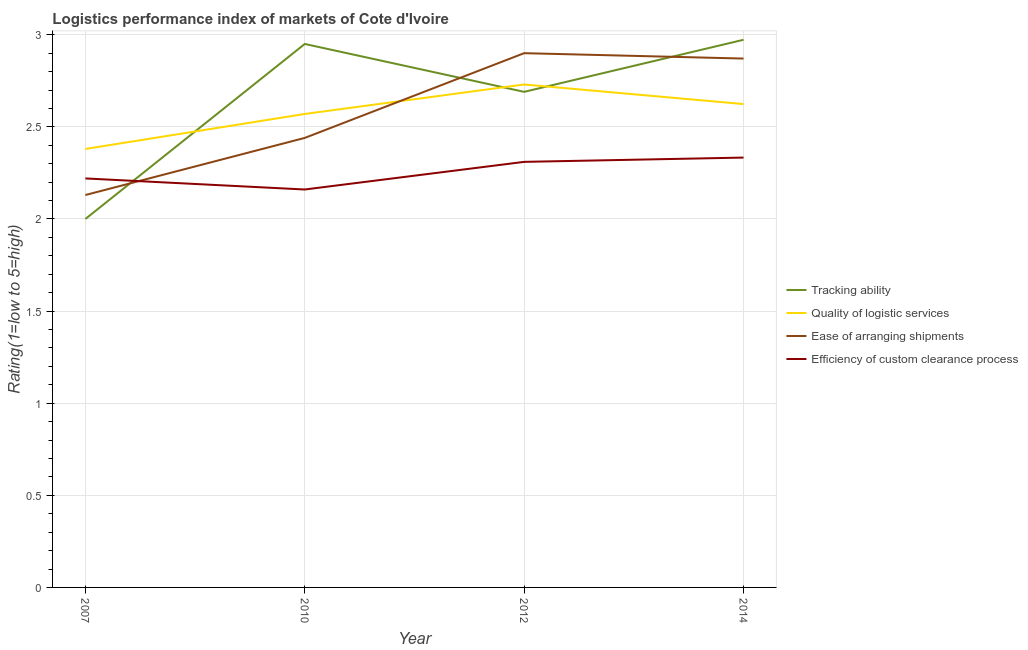How many different coloured lines are there?
Make the answer very short. 4. Does the line corresponding to lpi rating of efficiency of custom clearance process intersect with the line corresponding to lpi rating of quality of logistic services?
Provide a succinct answer. No. Is the number of lines equal to the number of legend labels?
Your response must be concise. Yes. What is the lpi rating of tracking ability in 2007?
Make the answer very short. 2. Across all years, what is the minimum lpi rating of ease of arranging shipments?
Ensure brevity in your answer.  2.13. In which year was the lpi rating of quality of logistic services maximum?
Your answer should be compact. 2012. What is the total lpi rating of efficiency of custom clearance process in the graph?
Offer a very short reply. 9.02. What is the difference between the lpi rating of quality of logistic services in 2012 and that in 2014?
Your answer should be very brief. 0.11. What is the difference between the lpi rating of quality of logistic services in 2014 and the lpi rating of ease of arranging shipments in 2007?
Make the answer very short. 0.49. What is the average lpi rating of ease of arranging shipments per year?
Offer a very short reply. 2.59. In the year 2012, what is the difference between the lpi rating of quality of logistic services and lpi rating of efficiency of custom clearance process?
Make the answer very short. 0.42. What is the ratio of the lpi rating of tracking ability in 2007 to that in 2012?
Your answer should be very brief. 0.74. Is the lpi rating of efficiency of custom clearance process in 2010 less than that in 2012?
Your answer should be compact. Yes. Is the difference between the lpi rating of quality of logistic services in 2007 and 2012 greater than the difference between the lpi rating of ease of arranging shipments in 2007 and 2012?
Give a very brief answer. Yes. What is the difference between the highest and the second highest lpi rating of tracking ability?
Make the answer very short. 0.02. What is the difference between the highest and the lowest lpi rating of ease of arranging shipments?
Offer a terse response. 0.77. In how many years, is the lpi rating of efficiency of custom clearance process greater than the average lpi rating of efficiency of custom clearance process taken over all years?
Your answer should be compact. 2. Is it the case that in every year, the sum of the lpi rating of efficiency of custom clearance process and lpi rating of ease of arranging shipments is greater than the sum of lpi rating of quality of logistic services and lpi rating of tracking ability?
Provide a succinct answer. No. How many lines are there?
Offer a very short reply. 4. Does the graph contain any zero values?
Provide a succinct answer. No. Where does the legend appear in the graph?
Your answer should be compact. Center right. How many legend labels are there?
Your response must be concise. 4. How are the legend labels stacked?
Give a very brief answer. Vertical. What is the title of the graph?
Provide a succinct answer. Logistics performance index of markets of Cote d'Ivoire. Does "Compensation of employees" appear as one of the legend labels in the graph?
Your response must be concise. No. What is the label or title of the X-axis?
Provide a short and direct response. Year. What is the label or title of the Y-axis?
Keep it short and to the point. Rating(1=low to 5=high). What is the Rating(1=low to 5=high) in Tracking ability in 2007?
Offer a very short reply. 2. What is the Rating(1=low to 5=high) of Quality of logistic services in 2007?
Your answer should be compact. 2.38. What is the Rating(1=low to 5=high) in Ease of arranging shipments in 2007?
Provide a succinct answer. 2.13. What is the Rating(1=low to 5=high) in Efficiency of custom clearance process in 2007?
Provide a short and direct response. 2.22. What is the Rating(1=low to 5=high) of Tracking ability in 2010?
Provide a succinct answer. 2.95. What is the Rating(1=low to 5=high) in Quality of logistic services in 2010?
Provide a succinct answer. 2.57. What is the Rating(1=low to 5=high) of Ease of arranging shipments in 2010?
Make the answer very short. 2.44. What is the Rating(1=low to 5=high) in Efficiency of custom clearance process in 2010?
Make the answer very short. 2.16. What is the Rating(1=low to 5=high) of Tracking ability in 2012?
Your answer should be compact. 2.69. What is the Rating(1=low to 5=high) in Quality of logistic services in 2012?
Give a very brief answer. 2.73. What is the Rating(1=low to 5=high) of Ease of arranging shipments in 2012?
Provide a short and direct response. 2.9. What is the Rating(1=low to 5=high) of Efficiency of custom clearance process in 2012?
Offer a terse response. 2.31. What is the Rating(1=low to 5=high) in Tracking ability in 2014?
Provide a short and direct response. 2.97. What is the Rating(1=low to 5=high) of Quality of logistic services in 2014?
Offer a terse response. 2.62. What is the Rating(1=low to 5=high) in Ease of arranging shipments in 2014?
Offer a very short reply. 2.87. What is the Rating(1=low to 5=high) in Efficiency of custom clearance process in 2014?
Your answer should be compact. 2.33. Across all years, what is the maximum Rating(1=low to 5=high) in Tracking ability?
Provide a short and direct response. 2.97. Across all years, what is the maximum Rating(1=low to 5=high) in Quality of logistic services?
Your answer should be very brief. 2.73. Across all years, what is the maximum Rating(1=low to 5=high) in Efficiency of custom clearance process?
Provide a short and direct response. 2.33. Across all years, what is the minimum Rating(1=low to 5=high) in Tracking ability?
Make the answer very short. 2. Across all years, what is the minimum Rating(1=low to 5=high) of Quality of logistic services?
Provide a short and direct response. 2.38. Across all years, what is the minimum Rating(1=low to 5=high) of Ease of arranging shipments?
Offer a very short reply. 2.13. Across all years, what is the minimum Rating(1=low to 5=high) of Efficiency of custom clearance process?
Provide a succinct answer. 2.16. What is the total Rating(1=low to 5=high) in Tracking ability in the graph?
Make the answer very short. 10.61. What is the total Rating(1=low to 5=high) in Quality of logistic services in the graph?
Your response must be concise. 10.3. What is the total Rating(1=low to 5=high) of Ease of arranging shipments in the graph?
Offer a very short reply. 10.34. What is the total Rating(1=low to 5=high) in Efficiency of custom clearance process in the graph?
Offer a very short reply. 9.02. What is the difference between the Rating(1=low to 5=high) of Tracking ability in 2007 and that in 2010?
Provide a short and direct response. -0.95. What is the difference between the Rating(1=low to 5=high) of Quality of logistic services in 2007 and that in 2010?
Give a very brief answer. -0.19. What is the difference between the Rating(1=low to 5=high) in Ease of arranging shipments in 2007 and that in 2010?
Give a very brief answer. -0.31. What is the difference between the Rating(1=low to 5=high) in Tracking ability in 2007 and that in 2012?
Provide a short and direct response. -0.69. What is the difference between the Rating(1=low to 5=high) of Quality of logistic services in 2007 and that in 2012?
Your answer should be compact. -0.35. What is the difference between the Rating(1=low to 5=high) in Ease of arranging shipments in 2007 and that in 2012?
Keep it short and to the point. -0.77. What is the difference between the Rating(1=low to 5=high) in Efficiency of custom clearance process in 2007 and that in 2012?
Make the answer very short. -0.09. What is the difference between the Rating(1=low to 5=high) in Tracking ability in 2007 and that in 2014?
Make the answer very short. -0.97. What is the difference between the Rating(1=low to 5=high) in Quality of logistic services in 2007 and that in 2014?
Give a very brief answer. -0.24. What is the difference between the Rating(1=low to 5=high) of Ease of arranging shipments in 2007 and that in 2014?
Provide a succinct answer. -0.74. What is the difference between the Rating(1=low to 5=high) of Efficiency of custom clearance process in 2007 and that in 2014?
Provide a short and direct response. -0.11. What is the difference between the Rating(1=low to 5=high) of Tracking ability in 2010 and that in 2012?
Provide a succinct answer. 0.26. What is the difference between the Rating(1=low to 5=high) in Quality of logistic services in 2010 and that in 2012?
Offer a very short reply. -0.16. What is the difference between the Rating(1=low to 5=high) in Ease of arranging shipments in 2010 and that in 2012?
Provide a short and direct response. -0.46. What is the difference between the Rating(1=low to 5=high) in Efficiency of custom clearance process in 2010 and that in 2012?
Your answer should be very brief. -0.15. What is the difference between the Rating(1=low to 5=high) of Tracking ability in 2010 and that in 2014?
Offer a very short reply. -0.02. What is the difference between the Rating(1=low to 5=high) of Quality of logistic services in 2010 and that in 2014?
Ensure brevity in your answer.  -0.05. What is the difference between the Rating(1=low to 5=high) in Ease of arranging shipments in 2010 and that in 2014?
Your answer should be compact. -0.43. What is the difference between the Rating(1=low to 5=high) in Efficiency of custom clearance process in 2010 and that in 2014?
Make the answer very short. -0.17. What is the difference between the Rating(1=low to 5=high) in Tracking ability in 2012 and that in 2014?
Offer a very short reply. -0.28. What is the difference between the Rating(1=low to 5=high) in Quality of logistic services in 2012 and that in 2014?
Offer a very short reply. 0.11. What is the difference between the Rating(1=low to 5=high) of Ease of arranging shipments in 2012 and that in 2014?
Your answer should be compact. 0.03. What is the difference between the Rating(1=low to 5=high) in Efficiency of custom clearance process in 2012 and that in 2014?
Your response must be concise. -0.02. What is the difference between the Rating(1=low to 5=high) of Tracking ability in 2007 and the Rating(1=low to 5=high) of Quality of logistic services in 2010?
Give a very brief answer. -0.57. What is the difference between the Rating(1=low to 5=high) in Tracking ability in 2007 and the Rating(1=low to 5=high) in Ease of arranging shipments in 2010?
Keep it short and to the point. -0.44. What is the difference between the Rating(1=low to 5=high) in Tracking ability in 2007 and the Rating(1=low to 5=high) in Efficiency of custom clearance process in 2010?
Keep it short and to the point. -0.16. What is the difference between the Rating(1=low to 5=high) in Quality of logistic services in 2007 and the Rating(1=low to 5=high) in Ease of arranging shipments in 2010?
Make the answer very short. -0.06. What is the difference between the Rating(1=low to 5=high) in Quality of logistic services in 2007 and the Rating(1=low to 5=high) in Efficiency of custom clearance process in 2010?
Your response must be concise. 0.22. What is the difference between the Rating(1=low to 5=high) of Ease of arranging shipments in 2007 and the Rating(1=low to 5=high) of Efficiency of custom clearance process in 2010?
Give a very brief answer. -0.03. What is the difference between the Rating(1=low to 5=high) of Tracking ability in 2007 and the Rating(1=low to 5=high) of Quality of logistic services in 2012?
Offer a very short reply. -0.73. What is the difference between the Rating(1=low to 5=high) in Tracking ability in 2007 and the Rating(1=low to 5=high) in Ease of arranging shipments in 2012?
Offer a very short reply. -0.9. What is the difference between the Rating(1=low to 5=high) of Tracking ability in 2007 and the Rating(1=low to 5=high) of Efficiency of custom clearance process in 2012?
Make the answer very short. -0.31. What is the difference between the Rating(1=low to 5=high) of Quality of logistic services in 2007 and the Rating(1=low to 5=high) of Ease of arranging shipments in 2012?
Make the answer very short. -0.52. What is the difference between the Rating(1=low to 5=high) of Quality of logistic services in 2007 and the Rating(1=low to 5=high) of Efficiency of custom clearance process in 2012?
Provide a succinct answer. 0.07. What is the difference between the Rating(1=low to 5=high) in Ease of arranging shipments in 2007 and the Rating(1=low to 5=high) in Efficiency of custom clearance process in 2012?
Make the answer very short. -0.18. What is the difference between the Rating(1=low to 5=high) in Tracking ability in 2007 and the Rating(1=low to 5=high) in Quality of logistic services in 2014?
Your response must be concise. -0.62. What is the difference between the Rating(1=low to 5=high) of Tracking ability in 2007 and the Rating(1=low to 5=high) of Ease of arranging shipments in 2014?
Make the answer very short. -0.87. What is the difference between the Rating(1=low to 5=high) of Tracking ability in 2007 and the Rating(1=low to 5=high) of Efficiency of custom clearance process in 2014?
Make the answer very short. -0.33. What is the difference between the Rating(1=low to 5=high) of Quality of logistic services in 2007 and the Rating(1=low to 5=high) of Ease of arranging shipments in 2014?
Your answer should be compact. -0.49. What is the difference between the Rating(1=low to 5=high) of Quality of logistic services in 2007 and the Rating(1=low to 5=high) of Efficiency of custom clearance process in 2014?
Ensure brevity in your answer.  0.05. What is the difference between the Rating(1=low to 5=high) in Ease of arranging shipments in 2007 and the Rating(1=low to 5=high) in Efficiency of custom clearance process in 2014?
Provide a succinct answer. -0.2. What is the difference between the Rating(1=low to 5=high) of Tracking ability in 2010 and the Rating(1=low to 5=high) of Quality of logistic services in 2012?
Keep it short and to the point. 0.22. What is the difference between the Rating(1=low to 5=high) in Tracking ability in 2010 and the Rating(1=low to 5=high) in Efficiency of custom clearance process in 2012?
Your answer should be compact. 0.64. What is the difference between the Rating(1=low to 5=high) of Quality of logistic services in 2010 and the Rating(1=low to 5=high) of Ease of arranging shipments in 2012?
Provide a short and direct response. -0.33. What is the difference between the Rating(1=low to 5=high) in Quality of logistic services in 2010 and the Rating(1=low to 5=high) in Efficiency of custom clearance process in 2012?
Offer a terse response. 0.26. What is the difference between the Rating(1=low to 5=high) in Ease of arranging shipments in 2010 and the Rating(1=low to 5=high) in Efficiency of custom clearance process in 2012?
Provide a succinct answer. 0.13. What is the difference between the Rating(1=low to 5=high) of Tracking ability in 2010 and the Rating(1=low to 5=high) of Quality of logistic services in 2014?
Offer a terse response. 0.33. What is the difference between the Rating(1=low to 5=high) of Tracking ability in 2010 and the Rating(1=low to 5=high) of Ease of arranging shipments in 2014?
Your answer should be very brief. 0.08. What is the difference between the Rating(1=low to 5=high) of Tracking ability in 2010 and the Rating(1=low to 5=high) of Efficiency of custom clearance process in 2014?
Provide a succinct answer. 0.62. What is the difference between the Rating(1=low to 5=high) in Quality of logistic services in 2010 and the Rating(1=low to 5=high) in Ease of arranging shipments in 2014?
Ensure brevity in your answer.  -0.3. What is the difference between the Rating(1=low to 5=high) in Quality of logistic services in 2010 and the Rating(1=low to 5=high) in Efficiency of custom clearance process in 2014?
Your answer should be very brief. 0.24. What is the difference between the Rating(1=low to 5=high) in Ease of arranging shipments in 2010 and the Rating(1=low to 5=high) in Efficiency of custom clearance process in 2014?
Give a very brief answer. 0.11. What is the difference between the Rating(1=low to 5=high) of Tracking ability in 2012 and the Rating(1=low to 5=high) of Quality of logistic services in 2014?
Offer a very short reply. 0.07. What is the difference between the Rating(1=low to 5=high) in Tracking ability in 2012 and the Rating(1=low to 5=high) in Ease of arranging shipments in 2014?
Your answer should be very brief. -0.18. What is the difference between the Rating(1=low to 5=high) of Tracking ability in 2012 and the Rating(1=low to 5=high) of Efficiency of custom clearance process in 2014?
Provide a short and direct response. 0.36. What is the difference between the Rating(1=low to 5=high) in Quality of logistic services in 2012 and the Rating(1=low to 5=high) in Ease of arranging shipments in 2014?
Give a very brief answer. -0.14. What is the difference between the Rating(1=low to 5=high) in Quality of logistic services in 2012 and the Rating(1=low to 5=high) in Efficiency of custom clearance process in 2014?
Your answer should be very brief. 0.4. What is the difference between the Rating(1=low to 5=high) in Ease of arranging shipments in 2012 and the Rating(1=low to 5=high) in Efficiency of custom clearance process in 2014?
Your answer should be compact. 0.57. What is the average Rating(1=low to 5=high) in Tracking ability per year?
Give a very brief answer. 2.65. What is the average Rating(1=low to 5=high) of Quality of logistic services per year?
Give a very brief answer. 2.58. What is the average Rating(1=low to 5=high) in Ease of arranging shipments per year?
Keep it short and to the point. 2.59. What is the average Rating(1=low to 5=high) in Efficiency of custom clearance process per year?
Make the answer very short. 2.26. In the year 2007, what is the difference between the Rating(1=low to 5=high) in Tracking ability and Rating(1=low to 5=high) in Quality of logistic services?
Ensure brevity in your answer.  -0.38. In the year 2007, what is the difference between the Rating(1=low to 5=high) of Tracking ability and Rating(1=low to 5=high) of Ease of arranging shipments?
Make the answer very short. -0.13. In the year 2007, what is the difference between the Rating(1=low to 5=high) of Tracking ability and Rating(1=low to 5=high) of Efficiency of custom clearance process?
Provide a succinct answer. -0.22. In the year 2007, what is the difference between the Rating(1=low to 5=high) in Quality of logistic services and Rating(1=low to 5=high) in Ease of arranging shipments?
Make the answer very short. 0.25. In the year 2007, what is the difference between the Rating(1=low to 5=high) of Quality of logistic services and Rating(1=low to 5=high) of Efficiency of custom clearance process?
Offer a very short reply. 0.16. In the year 2007, what is the difference between the Rating(1=low to 5=high) in Ease of arranging shipments and Rating(1=low to 5=high) in Efficiency of custom clearance process?
Your response must be concise. -0.09. In the year 2010, what is the difference between the Rating(1=low to 5=high) of Tracking ability and Rating(1=low to 5=high) of Quality of logistic services?
Your response must be concise. 0.38. In the year 2010, what is the difference between the Rating(1=low to 5=high) of Tracking ability and Rating(1=low to 5=high) of Ease of arranging shipments?
Your answer should be compact. 0.51. In the year 2010, what is the difference between the Rating(1=low to 5=high) of Tracking ability and Rating(1=low to 5=high) of Efficiency of custom clearance process?
Provide a succinct answer. 0.79. In the year 2010, what is the difference between the Rating(1=low to 5=high) of Quality of logistic services and Rating(1=low to 5=high) of Ease of arranging shipments?
Your answer should be compact. 0.13. In the year 2010, what is the difference between the Rating(1=low to 5=high) of Quality of logistic services and Rating(1=low to 5=high) of Efficiency of custom clearance process?
Provide a short and direct response. 0.41. In the year 2010, what is the difference between the Rating(1=low to 5=high) of Ease of arranging shipments and Rating(1=low to 5=high) of Efficiency of custom clearance process?
Offer a terse response. 0.28. In the year 2012, what is the difference between the Rating(1=low to 5=high) of Tracking ability and Rating(1=low to 5=high) of Quality of logistic services?
Your answer should be very brief. -0.04. In the year 2012, what is the difference between the Rating(1=low to 5=high) of Tracking ability and Rating(1=low to 5=high) of Ease of arranging shipments?
Offer a terse response. -0.21. In the year 2012, what is the difference between the Rating(1=low to 5=high) in Tracking ability and Rating(1=low to 5=high) in Efficiency of custom clearance process?
Your response must be concise. 0.38. In the year 2012, what is the difference between the Rating(1=low to 5=high) in Quality of logistic services and Rating(1=low to 5=high) in Ease of arranging shipments?
Provide a short and direct response. -0.17. In the year 2012, what is the difference between the Rating(1=low to 5=high) in Quality of logistic services and Rating(1=low to 5=high) in Efficiency of custom clearance process?
Keep it short and to the point. 0.42. In the year 2012, what is the difference between the Rating(1=low to 5=high) in Ease of arranging shipments and Rating(1=low to 5=high) in Efficiency of custom clearance process?
Your response must be concise. 0.59. In the year 2014, what is the difference between the Rating(1=low to 5=high) in Tracking ability and Rating(1=low to 5=high) in Quality of logistic services?
Keep it short and to the point. 0.35. In the year 2014, what is the difference between the Rating(1=low to 5=high) in Tracking ability and Rating(1=low to 5=high) in Ease of arranging shipments?
Offer a terse response. 0.1. In the year 2014, what is the difference between the Rating(1=low to 5=high) in Tracking ability and Rating(1=low to 5=high) in Efficiency of custom clearance process?
Offer a terse response. 0.64. In the year 2014, what is the difference between the Rating(1=low to 5=high) of Quality of logistic services and Rating(1=low to 5=high) of Ease of arranging shipments?
Keep it short and to the point. -0.25. In the year 2014, what is the difference between the Rating(1=low to 5=high) of Quality of logistic services and Rating(1=low to 5=high) of Efficiency of custom clearance process?
Provide a short and direct response. 0.29. In the year 2014, what is the difference between the Rating(1=low to 5=high) in Ease of arranging shipments and Rating(1=low to 5=high) in Efficiency of custom clearance process?
Provide a succinct answer. 0.54. What is the ratio of the Rating(1=low to 5=high) in Tracking ability in 2007 to that in 2010?
Make the answer very short. 0.68. What is the ratio of the Rating(1=low to 5=high) in Quality of logistic services in 2007 to that in 2010?
Provide a short and direct response. 0.93. What is the ratio of the Rating(1=low to 5=high) of Ease of arranging shipments in 2007 to that in 2010?
Offer a very short reply. 0.87. What is the ratio of the Rating(1=low to 5=high) of Efficiency of custom clearance process in 2007 to that in 2010?
Offer a very short reply. 1.03. What is the ratio of the Rating(1=low to 5=high) in Tracking ability in 2007 to that in 2012?
Make the answer very short. 0.74. What is the ratio of the Rating(1=low to 5=high) of Quality of logistic services in 2007 to that in 2012?
Keep it short and to the point. 0.87. What is the ratio of the Rating(1=low to 5=high) in Ease of arranging shipments in 2007 to that in 2012?
Offer a very short reply. 0.73. What is the ratio of the Rating(1=low to 5=high) of Efficiency of custom clearance process in 2007 to that in 2012?
Provide a short and direct response. 0.96. What is the ratio of the Rating(1=low to 5=high) of Tracking ability in 2007 to that in 2014?
Keep it short and to the point. 0.67. What is the ratio of the Rating(1=low to 5=high) in Quality of logistic services in 2007 to that in 2014?
Your answer should be very brief. 0.91. What is the ratio of the Rating(1=low to 5=high) of Ease of arranging shipments in 2007 to that in 2014?
Keep it short and to the point. 0.74. What is the ratio of the Rating(1=low to 5=high) of Efficiency of custom clearance process in 2007 to that in 2014?
Provide a short and direct response. 0.95. What is the ratio of the Rating(1=low to 5=high) of Tracking ability in 2010 to that in 2012?
Offer a terse response. 1.1. What is the ratio of the Rating(1=low to 5=high) in Quality of logistic services in 2010 to that in 2012?
Your answer should be compact. 0.94. What is the ratio of the Rating(1=low to 5=high) of Ease of arranging shipments in 2010 to that in 2012?
Keep it short and to the point. 0.84. What is the ratio of the Rating(1=low to 5=high) of Efficiency of custom clearance process in 2010 to that in 2012?
Keep it short and to the point. 0.94. What is the ratio of the Rating(1=low to 5=high) of Tracking ability in 2010 to that in 2014?
Offer a terse response. 0.99. What is the ratio of the Rating(1=low to 5=high) of Quality of logistic services in 2010 to that in 2014?
Provide a short and direct response. 0.98. What is the ratio of the Rating(1=low to 5=high) of Ease of arranging shipments in 2010 to that in 2014?
Your response must be concise. 0.85. What is the ratio of the Rating(1=low to 5=high) in Efficiency of custom clearance process in 2010 to that in 2014?
Provide a short and direct response. 0.93. What is the ratio of the Rating(1=low to 5=high) of Tracking ability in 2012 to that in 2014?
Offer a terse response. 0.9. What is the ratio of the Rating(1=low to 5=high) of Quality of logistic services in 2012 to that in 2014?
Your response must be concise. 1.04. What is the ratio of the Rating(1=low to 5=high) of Ease of arranging shipments in 2012 to that in 2014?
Offer a very short reply. 1.01. What is the difference between the highest and the second highest Rating(1=low to 5=high) of Tracking ability?
Give a very brief answer. 0.02. What is the difference between the highest and the second highest Rating(1=low to 5=high) of Quality of logistic services?
Your response must be concise. 0.11. What is the difference between the highest and the second highest Rating(1=low to 5=high) in Ease of arranging shipments?
Give a very brief answer. 0.03. What is the difference between the highest and the second highest Rating(1=low to 5=high) of Efficiency of custom clearance process?
Ensure brevity in your answer.  0.02. What is the difference between the highest and the lowest Rating(1=low to 5=high) in Tracking ability?
Your answer should be compact. 0.97. What is the difference between the highest and the lowest Rating(1=low to 5=high) of Ease of arranging shipments?
Your answer should be very brief. 0.77. What is the difference between the highest and the lowest Rating(1=low to 5=high) in Efficiency of custom clearance process?
Offer a very short reply. 0.17. 